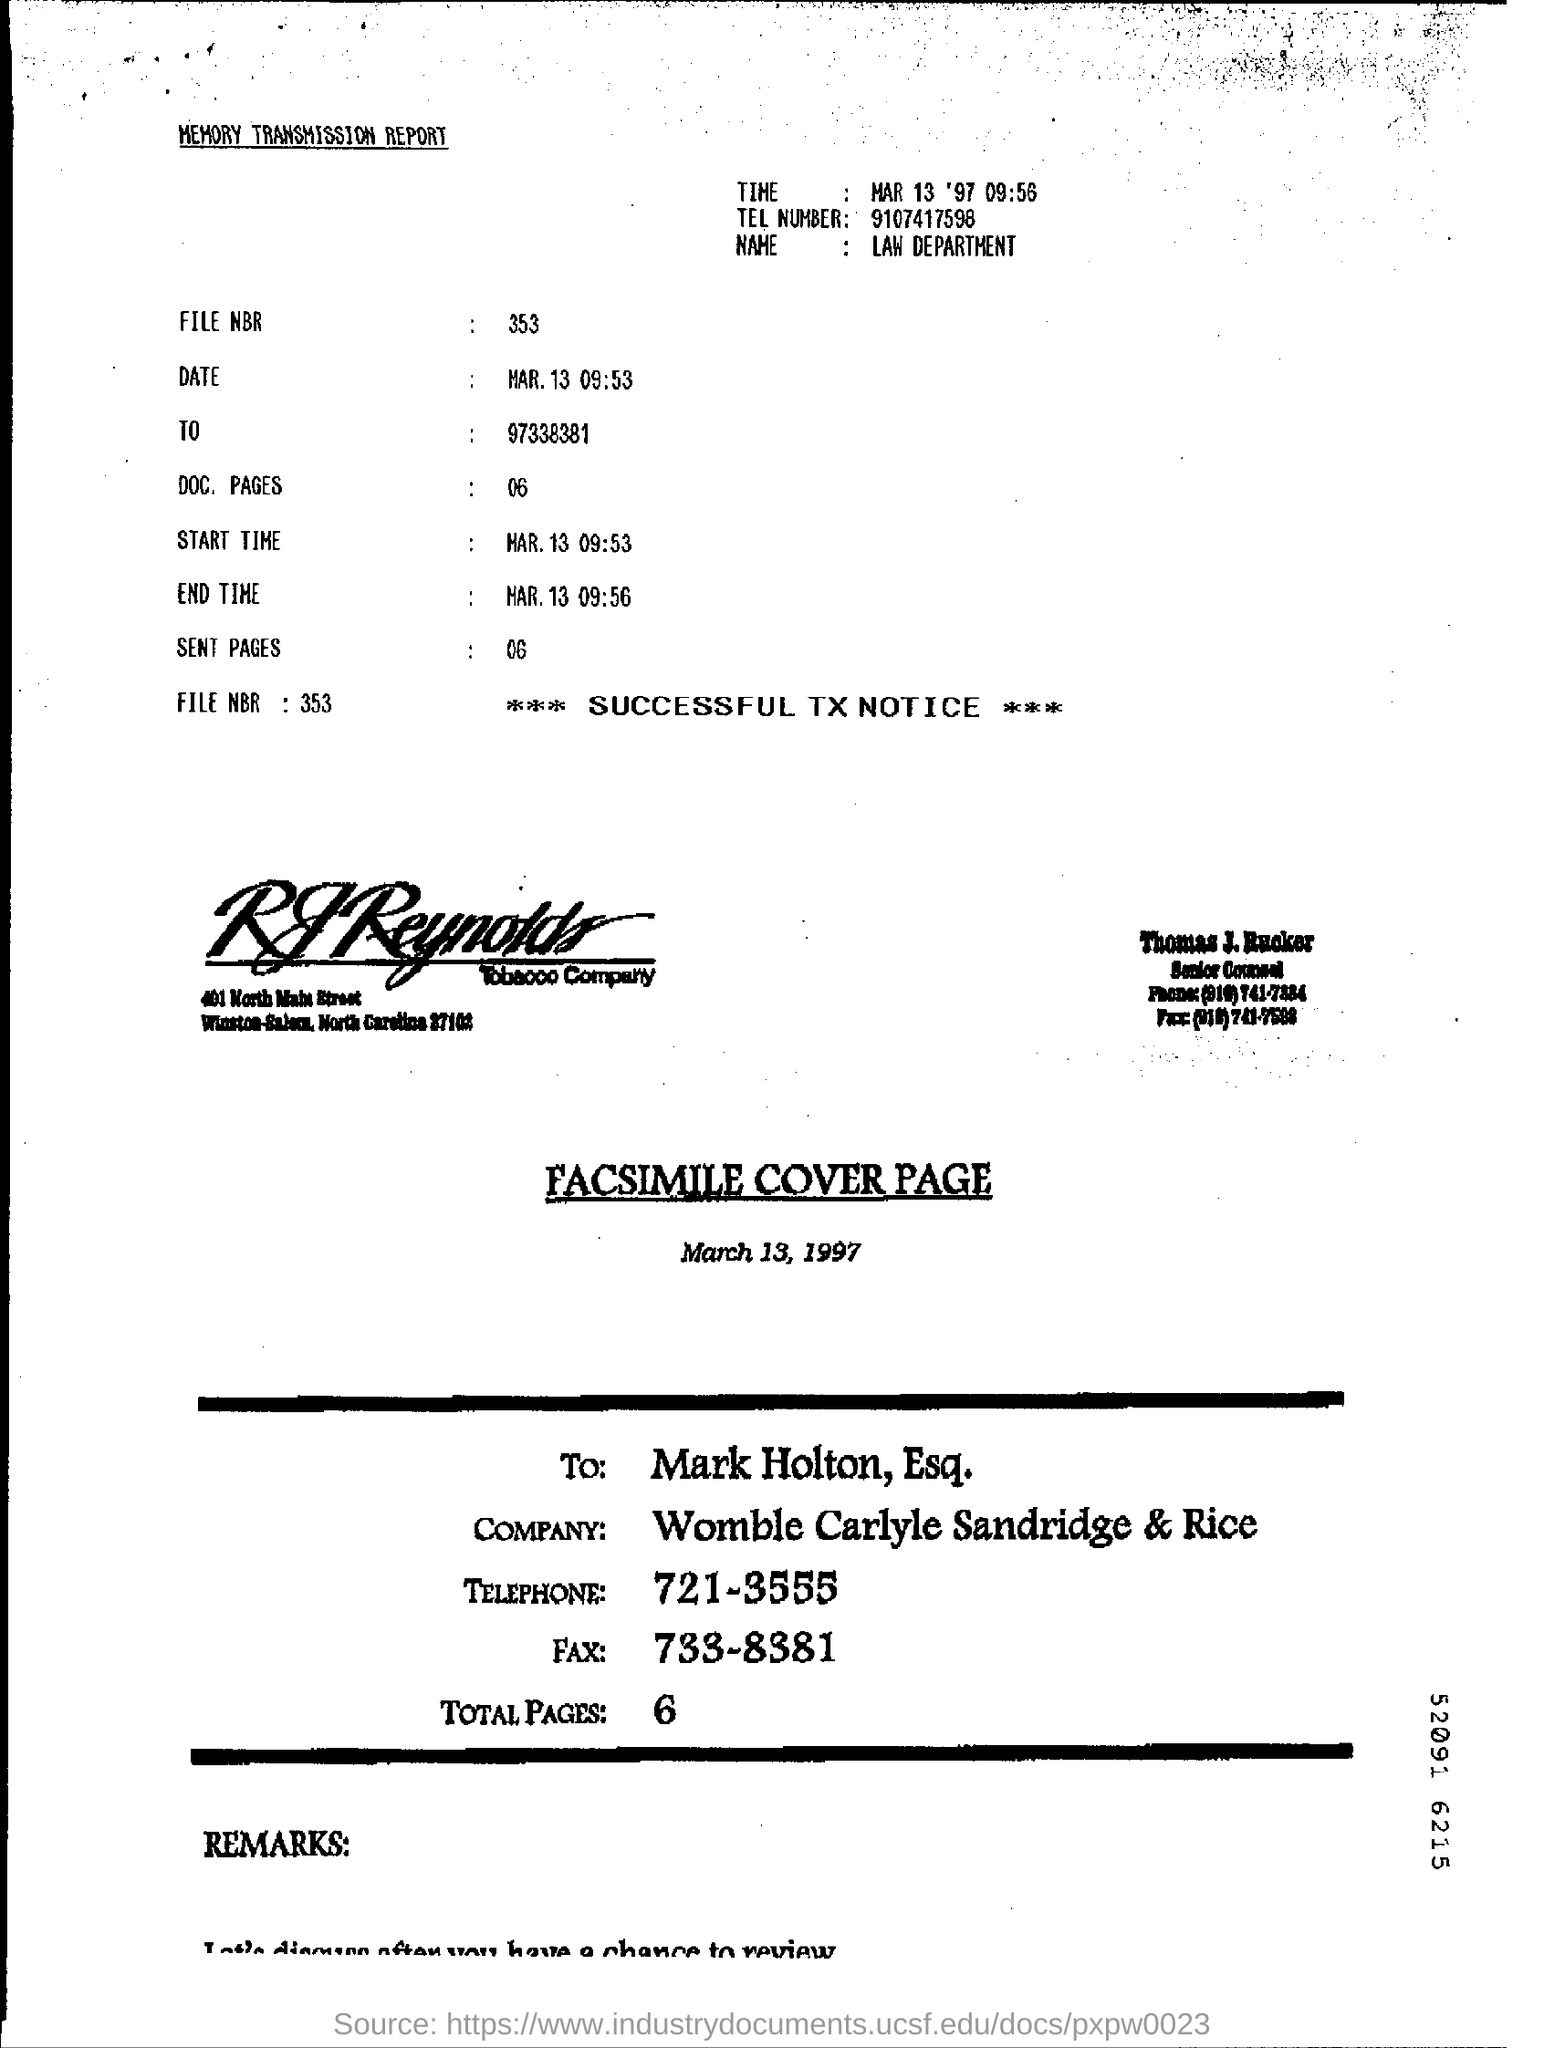What is the tel number?
Your answer should be very brief. 9107417598. What is the file nbr?
Give a very brief answer. 353. Number of doc pages?
Make the answer very short. 06. Number of sent pages?
Ensure brevity in your answer.  06. 